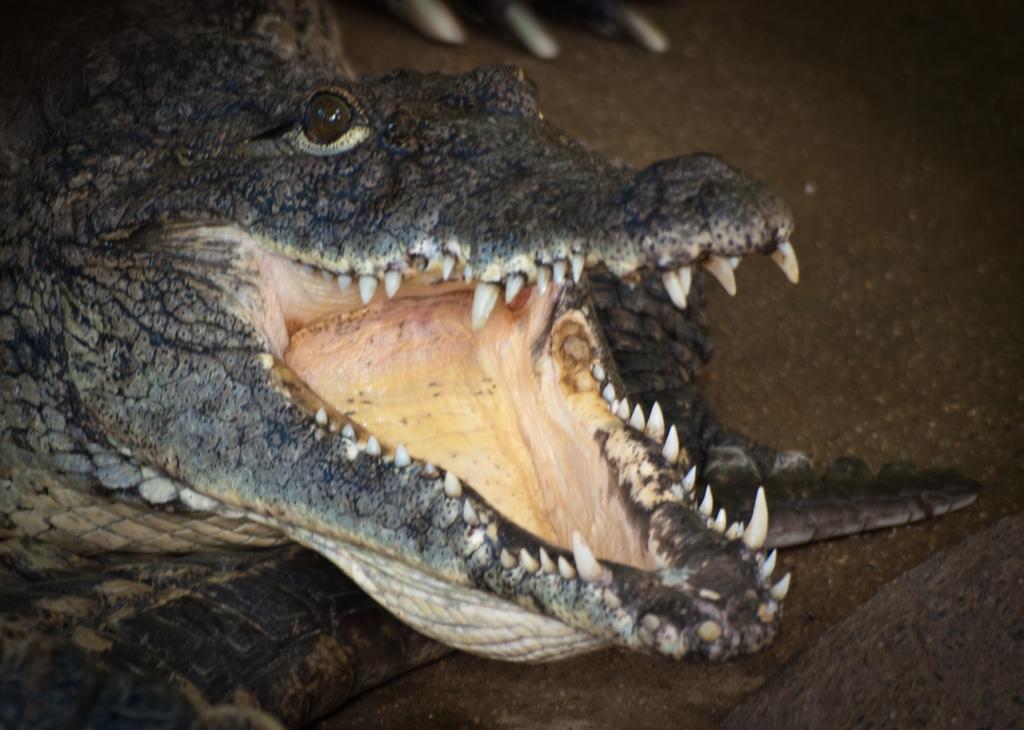In one or two sentences, can you explain what this image depicts? In this image we can see a crocodile on the ground. At the top the objects are not clear to describe. 